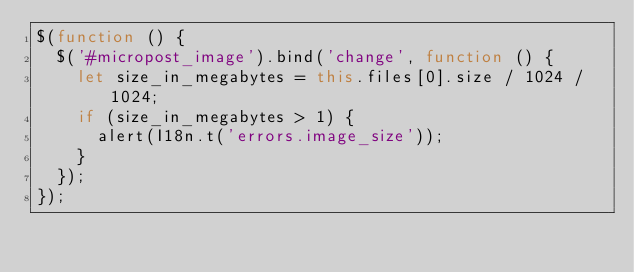<code> <loc_0><loc_0><loc_500><loc_500><_JavaScript_>$(function () {
  $('#micropost_image').bind('change', function () {
    let size_in_megabytes = this.files[0].size / 1024 / 1024;
    if (size_in_megabytes > 1) {
      alert(I18n.t('errors.image_size'));
    }
  });
});
</code> 